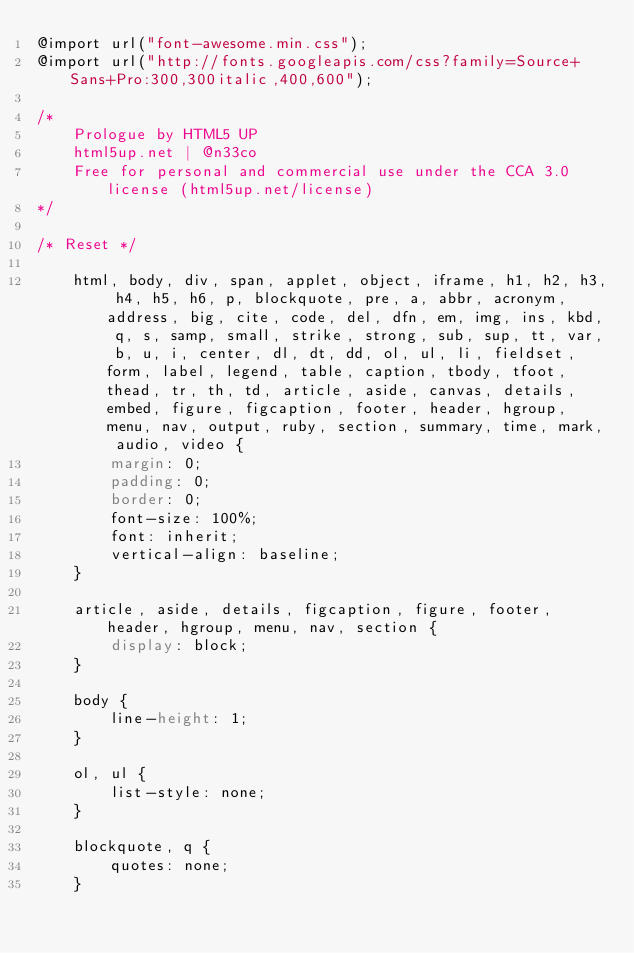<code> <loc_0><loc_0><loc_500><loc_500><_CSS_>@import url("font-awesome.min.css");
@import url("http://fonts.googleapis.com/css?family=Source+Sans+Pro:300,300italic,400,600");

/*
	Prologue by HTML5 UP
	html5up.net | @n33co
	Free for personal and commercial use under the CCA 3.0 license (html5up.net/license)
*/

/* Reset */

	html, body, div, span, applet, object, iframe, h1, h2, h3, h4, h5, h6, p, blockquote, pre, a, abbr, acronym, address, big, cite, code, del, dfn, em, img, ins, kbd, q, s, samp, small, strike, strong, sub, sup, tt, var, b, u, i, center, dl, dt, dd, ol, ul, li, fieldset, form, label, legend, table, caption, tbody, tfoot, thead, tr, th, td, article, aside, canvas, details, embed, figure, figcaption, footer, header, hgroup, menu, nav, output, ruby, section, summary, time, mark, audio, video {
		margin: 0;
		padding: 0;
		border: 0;
		font-size: 100%;
		font: inherit;
		vertical-align: baseline;
	}

	article, aside, details, figcaption, figure, footer, header, hgroup, menu, nav, section {
		display: block;
	}

	body {
		line-height: 1;
	}

	ol, ul {
		list-style: none;
	}

	blockquote, q {
		quotes: none;
	}
</code> 